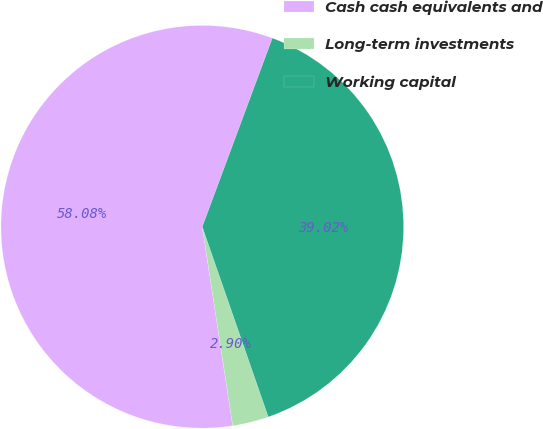Convert chart to OTSL. <chart><loc_0><loc_0><loc_500><loc_500><pie_chart><fcel>Cash cash equivalents and<fcel>Long-term investments<fcel>Working capital<nl><fcel>58.08%<fcel>2.9%<fcel>39.02%<nl></chart> 